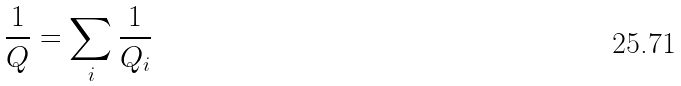<formula> <loc_0><loc_0><loc_500><loc_500>\frac { 1 } { Q } = \sum _ { i } \frac { 1 } { Q _ { i } }</formula> 